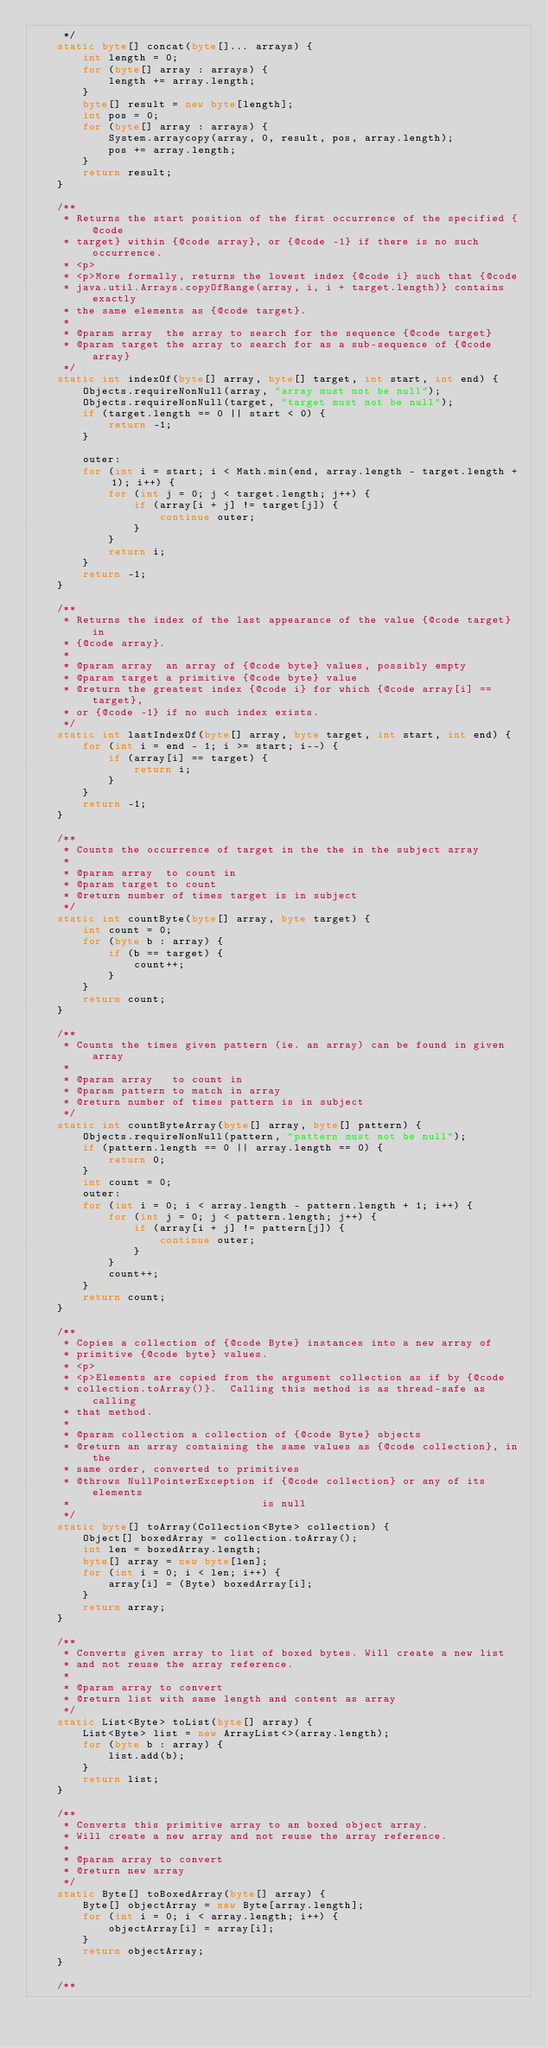Convert code to text. <code><loc_0><loc_0><loc_500><loc_500><_Java_>     */
    static byte[] concat(byte[]... arrays) {
        int length = 0;
        for (byte[] array : arrays) {
            length += array.length;
        }
        byte[] result = new byte[length];
        int pos = 0;
        for (byte[] array : arrays) {
            System.arraycopy(array, 0, result, pos, array.length);
            pos += array.length;
        }
        return result;
    }

    /**
     * Returns the start position of the first occurrence of the specified {@code
     * target} within {@code array}, or {@code -1} if there is no such occurrence.
     * <p>
     * <p>More formally, returns the lowest index {@code i} such that {@code
     * java.util.Arrays.copyOfRange(array, i, i + target.length)} contains exactly
     * the same elements as {@code target}.
     *
     * @param array  the array to search for the sequence {@code target}
     * @param target the array to search for as a sub-sequence of {@code array}
     */
    static int indexOf(byte[] array, byte[] target, int start, int end) {
        Objects.requireNonNull(array, "array must not be null");
        Objects.requireNonNull(target, "target must not be null");
        if (target.length == 0 || start < 0) {
            return -1;
        }

        outer:
        for (int i = start; i < Math.min(end, array.length - target.length + 1); i++) {
            for (int j = 0; j < target.length; j++) {
                if (array[i + j] != target[j]) {
                    continue outer;
                }
            }
            return i;
        }
        return -1;
    }

    /**
     * Returns the index of the last appearance of the value {@code target} in
     * {@code array}.
     *
     * @param array  an array of {@code byte} values, possibly empty
     * @param target a primitive {@code byte} value
     * @return the greatest index {@code i} for which {@code array[i] == target},
     * or {@code -1} if no such index exists.
     */
    static int lastIndexOf(byte[] array, byte target, int start, int end) {
        for (int i = end - 1; i >= start; i--) {
            if (array[i] == target) {
                return i;
            }
        }
        return -1;
    }

    /**
     * Counts the occurrence of target in the the in the subject array
     *
     * @param array  to count in
     * @param target to count
     * @return number of times target is in subject
     */
    static int countByte(byte[] array, byte target) {
        int count = 0;
        for (byte b : array) {
            if (b == target) {
                count++;
            }
        }
        return count;
    }

    /**
     * Counts the times given pattern (ie. an array) can be found in given array
     *
     * @param array   to count in
     * @param pattern to match in array
     * @return number of times pattern is in subject
     */
    static int countByteArray(byte[] array, byte[] pattern) {
        Objects.requireNonNull(pattern, "pattern must not be null");
        if (pattern.length == 0 || array.length == 0) {
            return 0;
        }
        int count = 0;
        outer:
        for (int i = 0; i < array.length - pattern.length + 1; i++) {
            for (int j = 0; j < pattern.length; j++) {
                if (array[i + j] != pattern[j]) {
                    continue outer;
                }
            }
            count++;
        }
        return count;
    }

    /**
     * Copies a collection of {@code Byte} instances into a new array of
     * primitive {@code byte} values.
     * <p>
     * <p>Elements are copied from the argument collection as if by {@code
     * collection.toArray()}.  Calling this method is as thread-safe as calling
     * that method.
     *
     * @param collection a collection of {@code Byte} objects
     * @return an array containing the same values as {@code collection}, in the
     * same order, converted to primitives
     * @throws NullPointerException if {@code collection} or any of its elements
     *                              is null
     */
    static byte[] toArray(Collection<Byte> collection) {
        Object[] boxedArray = collection.toArray();
        int len = boxedArray.length;
        byte[] array = new byte[len];
        for (int i = 0; i < len; i++) {
            array[i] = (Byte) boxedArray[i];
        }
        return array;
    }

    /**
     * Converts given array to list of boxed bytes. Will create a new list
     * and not reuse the array reference.
     *
     * @param array to convert
     * @return list with same length and content as array
     */
    static List<Byte> toList(byte[] array) {
        List<Byte> list = new ArrayList<>(array.length);
        for (byte b : array) {
            list.add(b);
        }
        return list;
    }

    /**
     * Converts this primitive array to an boxed object array.
     * Will create a new array and not reuse the array reference.
     *
     * @param array to convert
     * @return new array
     */
    static Byte[] toBoxedArray(byte[] array) {
        Byte[] objectArray = new Byte[array.length];
        for (int i = 0; i < array.length; i++) {
            objectArray[i] = array[i];
        }
        return objectArray;
    }

    /**</code> 